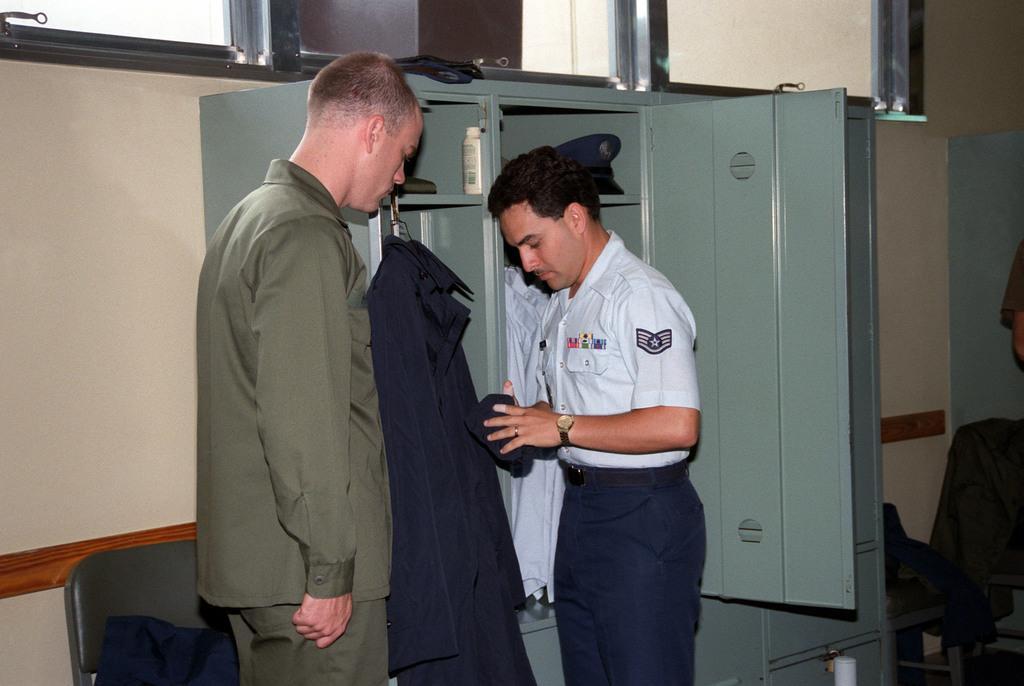Can you describe this image briefly? In the center of the image there are two persons. In the background of the image there is a almirah. There are clothes. In the background of the image there is wall. There are windows. 